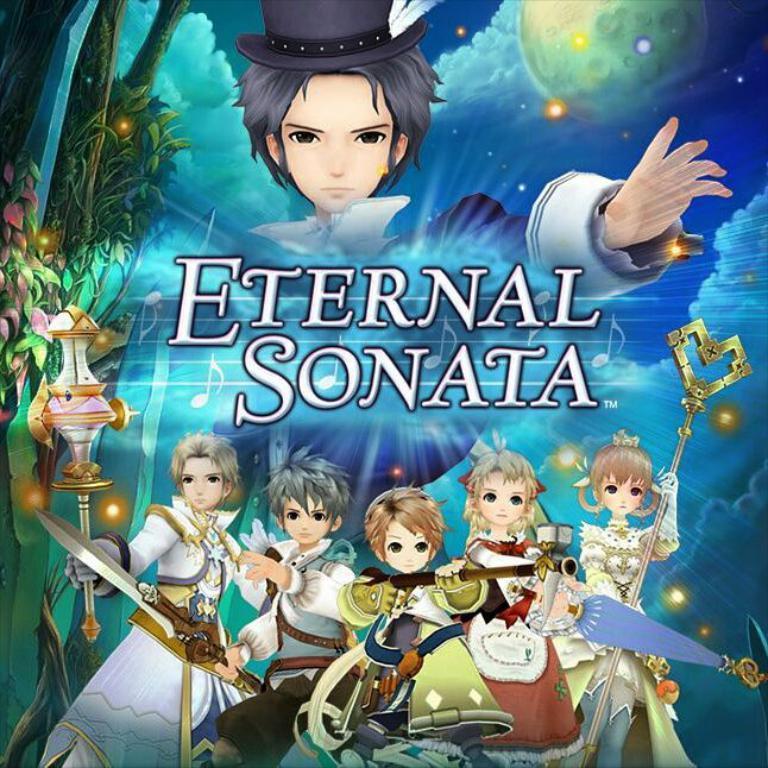Please provide a concise description of this image. Here in this picture we can see a poster with animated pictures on it and we can see a group of animated persons in the picture over there and we can see trees and clouds also present over there. 